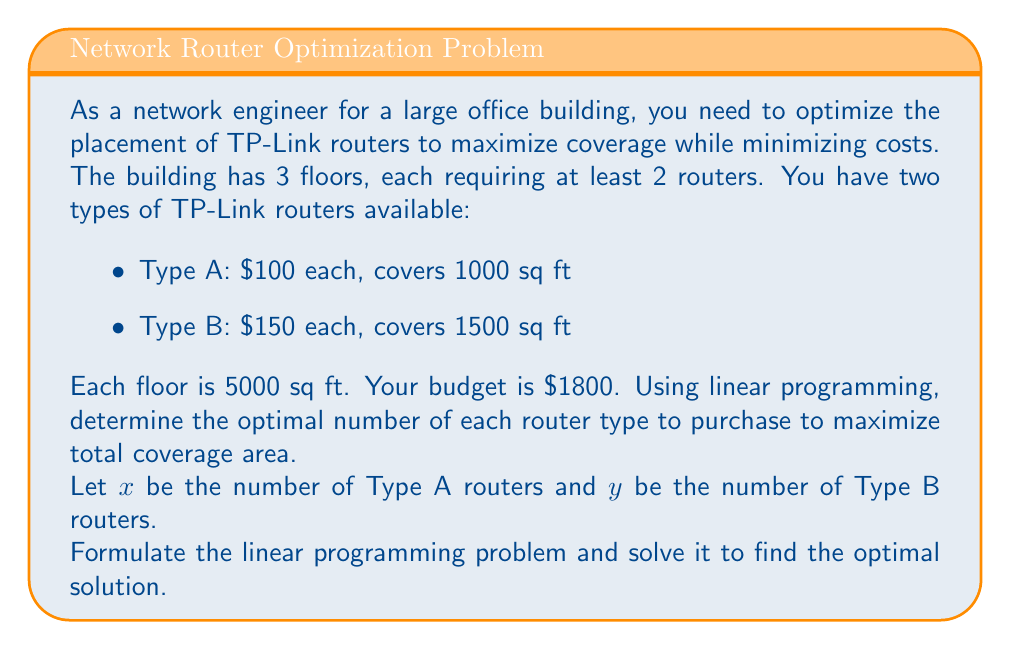Show me your answer to this math problem. Let's approach this step-by-step:

1) Objective function: Maximize total coverage area
   $$\text{Maximize } Z = 1000x + 1500y$$

2) Constraints:
   a) Budget constraint: $$100x + 150y \leq 1800$$
   b) Minimum 2 routers per floor (3 floors): $$x + y \geq 6$$
   c) Non-negativity: $$x \geq 0, y \geq 0$$

3) To solve this, we'll use the graphical method:

   [asy]
   import graph;
   size(200);
   xaxis("x", 0, 20);
   yaxis("y", 0, 15);
   draw((0,6)--(18,6), blue);
   draw((18,0)--(0,12), red);
   draw((0,7.5)--(15,0), green);
   label("Budget", (9,8), E, red);
   label("Min routers", (9,5), N, blue);
   label("Optimal", (7.5,3.75), SE, green);
   dot((6,6));
   dot((9,3));
   dot((0,12));
   [/asy]

4) The feasible region is bounded by the lines:
   - $x + y = 6$ (blue line)
   - $100x + 150y = 1800$ (red line)
   - $x = 0$ and $y = 0$ (axes)

5) The optimal solution will be at one of the corner points:
   (0, 12), (6, 6), or (9, 3)

6) Evaluating Z at these points:
   - Z(0, 12) = 0 + 1500(12) = 18,000
   - Z(6, 6) = 1000(6) + 1500(6) = 15,000
   - Z(9, 3) = 1000(9) + 1500(3) = 13,500

7) The maximum value of Z occurs at (0, 12)
Answer: 0 Type A routers, 12 Type B routers 